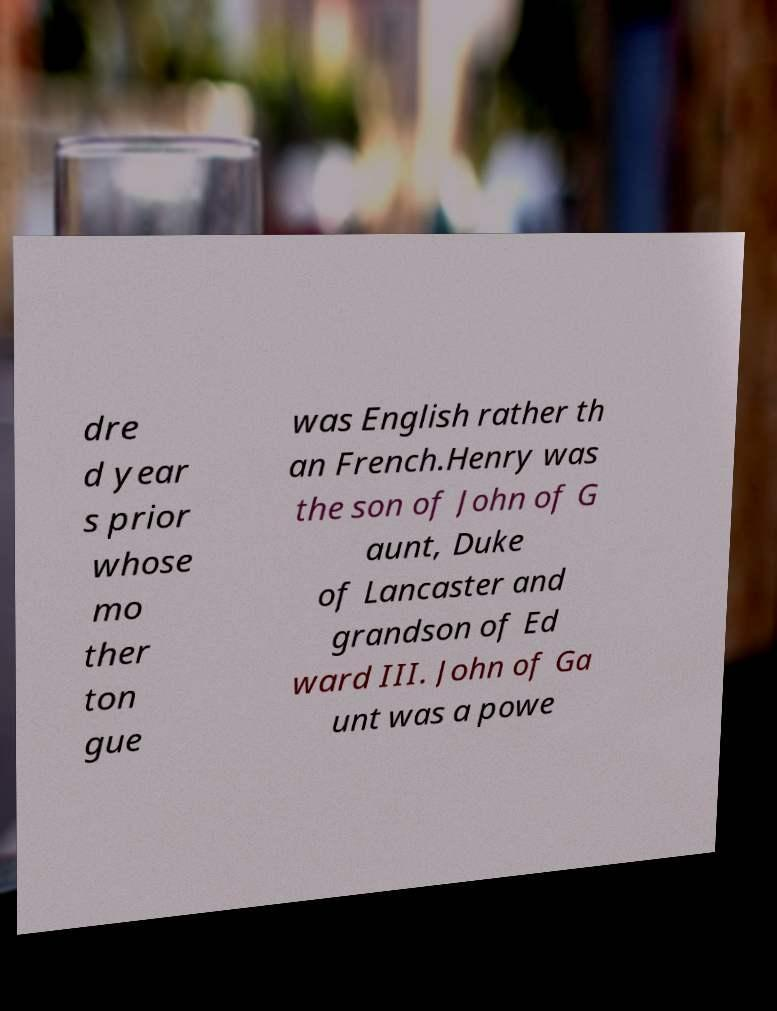I need the written content from this picture converted into text. Can you do that? dre d year s prior whose mo ther ton gue was English rather th an French.Henry was the son of John of G aunt, Duke of Lancaster and grandson of Ed ward III. John of Ga unt was a powe 